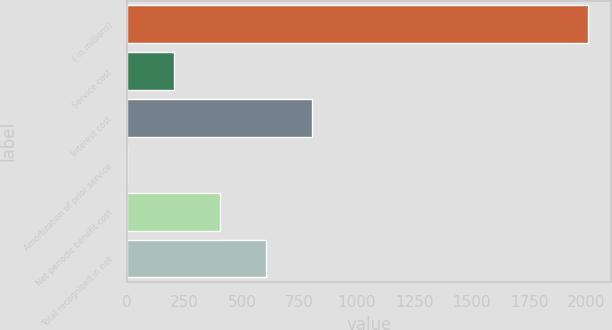Convert chart to OTSL. <chart><loc_0><loc_0><loc_500><loc_500><bar_chart><fcel>( in millions)<fcel>Service cost<fcel>Interest cost<fcel>Amortization of prior service<fcel>Net periodic benefit cost<fcel>Total recognized in net<nl><fcel>2006<fcel>201.23<fcel>802.82<fcel>0.7<fcel>401.76<fcel>602.29<nl></chart> 